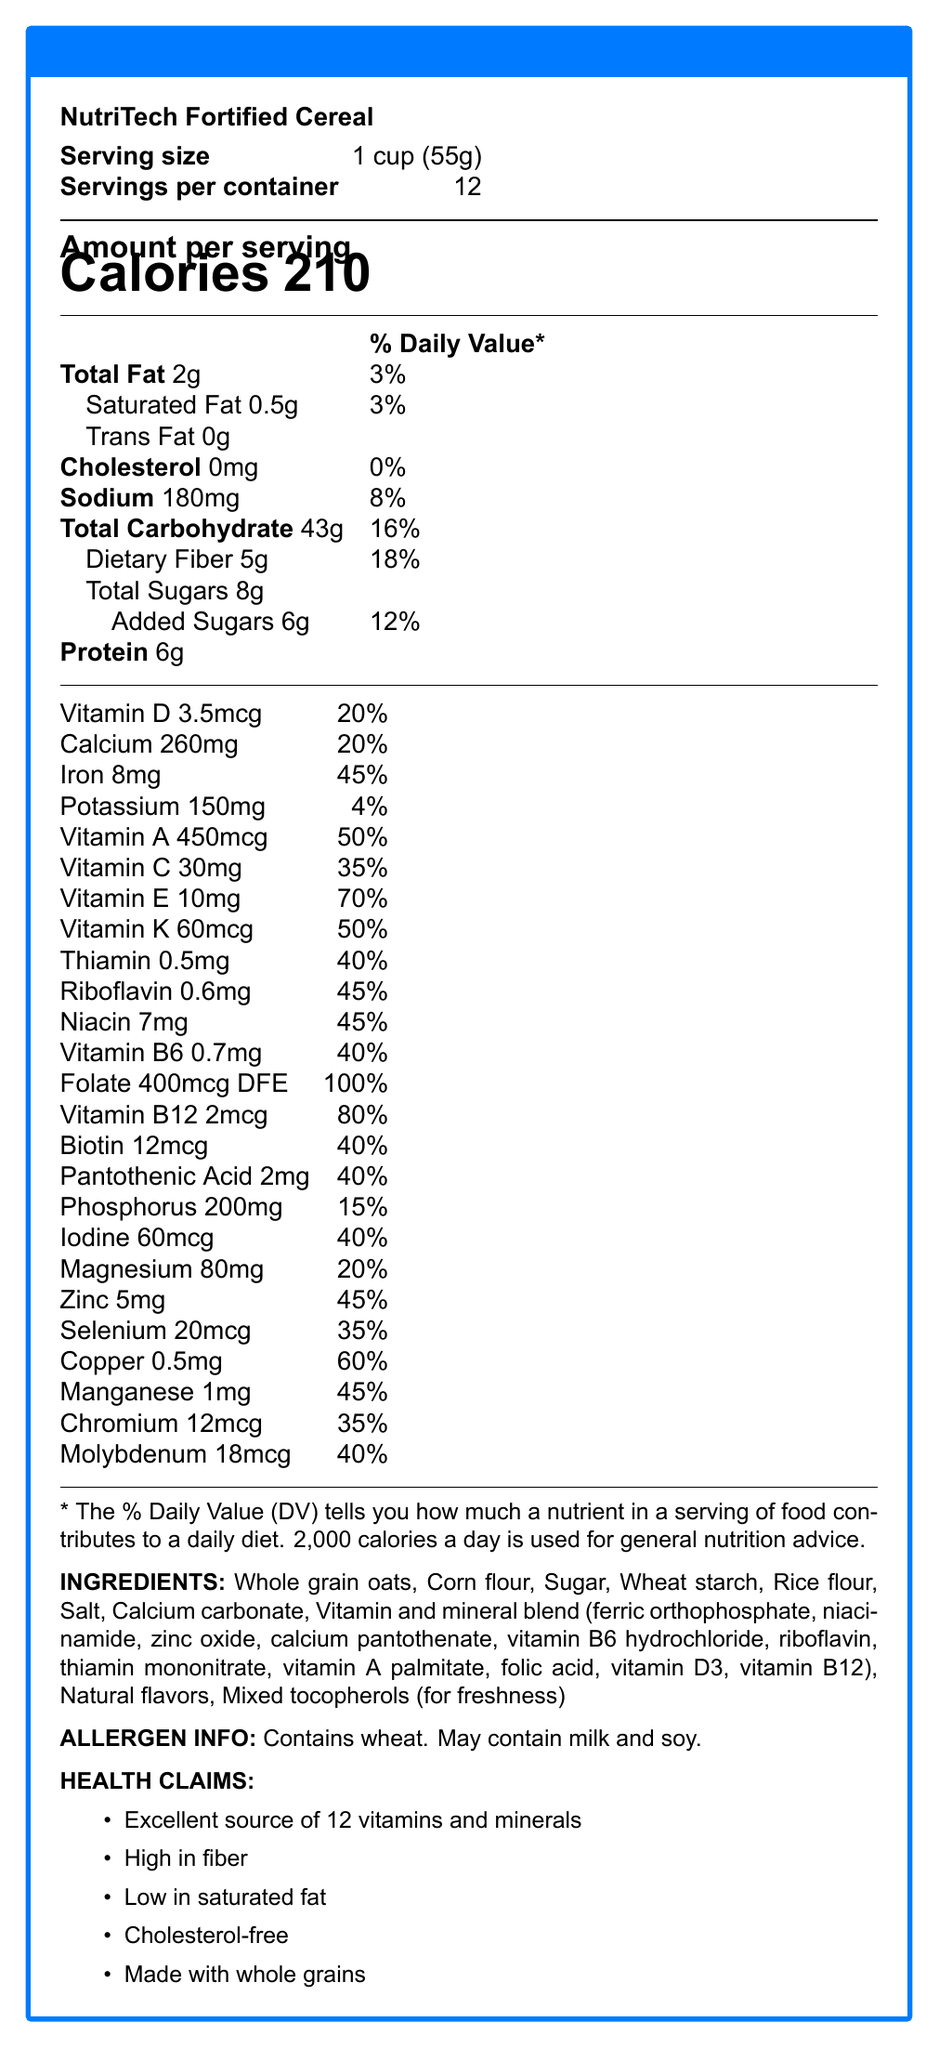what is the serving size? The document lists the serving size at the very beginning under the product name and servings information.
Answer: 1 cup (55g) how many servings are there per container? This information is clearly stated right next to the serving size at the beginning of the document.
Answer: 12 what is the caloric content per serving? The document displays the calorie count prominently under the "Amount per serving" section.
Answer: 210 calories how much dietary fiber is in one serving? The dietary fiber content is listed under the "Total Carbohydrate" section in the macronutrient breakdown.
Answer: 5g how many grams of total sugars are in one serving? The total sugar amount can be found under "Total Carbohydrate" in the document.
Answer: 8g how much Vitamin D is present per serving? The amount of Vitamin D can be found under the vitamins and minerals section towards the bottom of the document.
Answer: 3.5mcg which vitamins have a daily value of 45% per serving? A. Vitamin D and Vitamin B6 B. Niacin, Riboflavin, and Iron C. Vitamin E and Vitamin A D. Biotin and Pantothenic Acid Niacin, Riboflavin, and Iron each have a daily value of 45% per serving, as indicated in the nutritional details.
Answer: B which vitamin is present in the highest daily value percentage per serving? 1. Vitamin A 2. Vitamin E 3. Folate 4. Vitamin B12 The document indicates that Folate has a daily value percentage of 100%, which is the highest among the listed vitamins.
Answer: 3 how much iron does one serving contain? The document lists this information under the vitamins and minerals section.
Answer: 8mg is this cereal high in fiber? The document claims that the cereal is "High in fiber" under the health claims section, and it contains 5g of dietary fiber per serving, which is 18% of the daily value.
Answer: Yes summarize the nutritional highlights of this cereal. The document provides detailed information on nutrient content, ingredient list, allergen information, and various health claims emphasizing its benefits for health-conscious individuals.
Answer: NutriTech Fortified Cereal is a nutrient-rich option providing 210 calories per serving with minimal fats and no cholesterol. It is an excellent source of 12 vitamins and minerals including high levels of Vitamin E, Folate, Vitamin B12, and iron. Additionally, it is high in fiber, low in saturated fat, and made with whole grains. what is the main ingredient of this cereal? The ingredients list at the bottom of the document shows that the first ingredient is Whole grain oats.
Answer: Whole grain oats can you identify the source of the natural flavors in the cereal? The document lists "Natural flavors" as an ingredient but does not specify their source.
Answer: Not enough information how much sodium is in a serving? The amount of sodium is stated under the macronutrient breakdown section in the document.
Answer: 180mg how much potassium is present per serving? The potassium content is provided in the vitamins and minerals section of the document.
Answer: 150mg what percentage of the daily value of calcium does one serving provide? This can be found in the vitamins and minerals section where calcium content and percentage daily value are listed.
Answer: 20% what are the allergens listed for this product? The allergen information is clearly stated towards the bottom of the document.
Answer: Contains wheat. May contain milk and soy. how many ingredients are used in NutriTech Fortified Cereal? The ingredients list includes several components, with groups of ingredients like "Vitamin and mineral blend" counting as one.
Answer: 10 (Considering groups of ingredients as individual counts, e.g., Vitamin and mineral blend counts as 1.) which vitamins have a daily value percentage of 40%? i. Thiamin ii. Vitamin B6 iii. Biotin iv. Pantothenic Acid v. Riboflavin The vitamins Thiamin, Vitamin B6, Biotin, and Pantothenic Acid all have a daily value percentage of 40%, while Riboflavin is 45%.
Answer: i, ii, iii, iv 